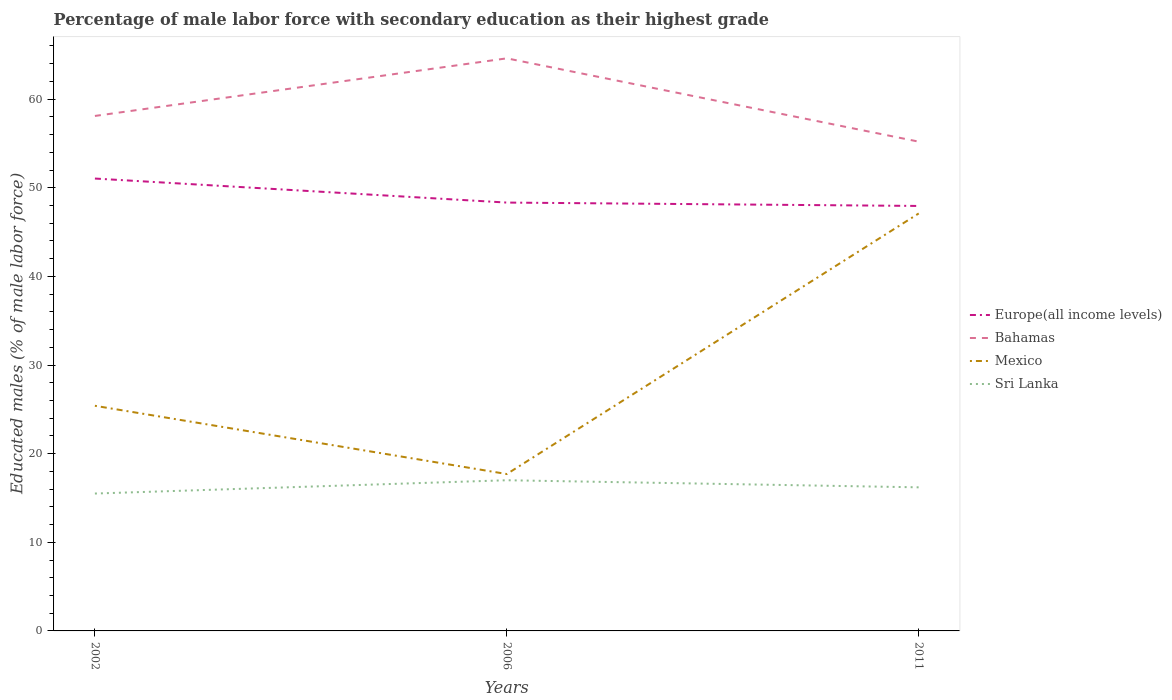Does the line corresponding to Europe(all income levels) intersect with the line corresponding to Bahamas?
Ensure brevity in your answer.  No. Across all years, what is the maximum percentage of male labor force with secondary education in Bahamas?
Your answer should be compact. 55.2. In which year was the percentage of male labor force with secondary education in Bahamas maximum?
Your answer should be compact. 2011. What is the total percentage of male labor force with secondary education in Europe(all income levels) in the graph?
Your answer should be compact. 3.09. What is the difference between the highest and the second highest percentage of male labor force with secondary education in Mexico?
Your response must be concise. 29.4. What is the difference between the highest and the lowest percentage of male labor force with secondary education in Sri Lanka?
Ensure brevity in your answer.  1. How many years are there in the graph?
Provide a short and direct response. 3. Are the values on the major ticks of Y-axis written in scientific E-notation?
Keep it short and to the point. No. Does the graph contain grids?
Give a very brief answer. No. Where does the legend appear in the graph?
Provide a succinct answer. Center right. How many legend labels are there?
Make the answer very short. 4. What is the title of the graph?
Make the answer very short. Percentage of male labor force with secondary education as their highest grade. What is the label or title of the X-axis?
Provide a succinct answer. Years. What is the label or title of the Y-axis?
Your answer should be compact. Educated males (% of male labor force). What is the Educated males (% of male labor force) of Europe(all income levels) in 2002?
Offer a terse response. 51.04. What is the Educated males (% of male labor force) in Bahamas in 2002?
Provide a succinct answer. 58.1. What is the Educated males (% of male labor force) in Mexico in 2002?
Your answer should be compact. 25.4. What is the Educated males (% of male labor force) in Europe(all income levels) in 2006?
Provide a short and direct response. 48.33. What is the Educated males (% of male labor force) of Bahamas in 2006?
Keep it short and to the point. 64.6. What is the Educated males (% of male labor force) in Mexico in 2006?
Give a very brief answer. 17.7. What is the Educated males (% of male labor force) of Sri Lanka in 2006?
Give a very brief answer. 17. What is the Educated males (% of male labor force) in Europe(all income levels) in 2011?
Keep it short and to the point. 47.95. What is the Educated males (% of male labor force) of Bahamas in 2011?
Offer a terse response. 55.2. What is the Educated males (% of male labor force) in Mexico in 2011?
Make the answer very short. 47.1. What is the Educated males (% of male labor force) of Sri Lanka in 2011?
Provide a succinct answer. 16.2. Across all years, what is the maximum Educated males (% of male labor force) in Europe(all income levels)?
Your answer should be very brief. 51.04. Across all years, what is the maximum Educated males (% of male labor force) in Bahamas?
Offer a very short reply. 64.6. Across all years, what is the maximum Educated males (% of male labor force) of Mexico?
Provide a succinct answer. 47.1. Across all years, what is the minimum Educated males (% of male labor force) of Europe(all income levels)?
Your answer should be very brief. 47.95. Across all years, what is the minimum Educated males (% of male labor force) in Bahamas?
Ensure brevity in your answer.  55.2. Across all years, what is the minimum Educated males (% of male labor force) of Mexico?
Offer a very short reply. 17.7. What is the total Educated males (% of male labor force) in Europe(all income levels) in the graph?
Provide a succinct answer. 147.31. What is the total Educated males (% of male labor force) of Bahamas in the graph?
Ensure brevity in your answer.  177.9. What is the total Educated males (% of male labor force) of Mexico in the graph?
Offer a very short reply. 90.2. What is the total Educated males (% of male labor force) in Sri Lanka in the graph?
Keep it short and to the point. 48.7. What is the difference between the Educated males (% of male labor force) of Europe(all income levels) in 2002 and that in 2006?
Offer a terse response. 2.71. What is the difference between the Educated males (% of male labor force) of Mexico in 2002 and that in 2006?
Your response must be concise. 7.7. What is the difference between the Educated males (% of male labor force) in Sri Lanka in 2002 and that in 2006?
Offer a terse response. -1.5. What is the difference between the Educated males (% of male labor force) in Europe(all income levels) in 2002 and that in 2011?
Give a very brief answer. 3.09. What is the difference between the Educated males (% of male labor force) in Bahamas in 2002 and that in 2011?
Provide a short and direct response. 2.9. What is the difference between the Educated males (% of male labor force) of Mexico in 2002 and that in 2011?
Give a very brief answer. -21.7. What is the difference between the Educated males (% of male labor force) of Sri Lanka in 2002 and that in 2011?
Your response must be concise. -0.7. What is the difference between the Educated males (% of male labor force) of Europe(all income levels) in 2006 and that in 2011?
Provide a short and direct response. 0.38. What is the difference between the Educated males (% of male labor force) of Mexico in 2006 and that in 2011?
Keep it short and to the point. -29.4. What is the difference between the Educated males (% of male labor force) in Europe(all income levels) in 2002 and the Educated males (% of male labor force) in Bahamas in 2006?
Offer a very short reply. -13.56. What is the difference between the Educated males (% of male labor force) of Europe(all income levels) in 2002 and the Educated males (% of male labor force) of Mexico in 2006?
Ensure brevity in your answer.  33.34. What is the difference between the Educated males (% of male labor force) of Europe(all income levels) in 2002 and the Educated males (% of male labor force) of Sri Lanka in 2006?
Provide a succinct answer. 34.04. What is the difference between the Educated males (% of male labor force) in Bahamas in 2002 and the Educated males (% of male labor force) in Mexico in 2006?
Ensure brevity in your answer.  40.4. What is the difference between the Educated males (% of male labor force) in Bahamas in 2002 and the Educated males (% of male labor force) in Sri Lanka in 2006?
Keep it short and to the point. 41.1. What is the difference between the Educated males (% of male labor force) of Mexico in 2002 and the Educated males (% of male labor force) of Sri Lanka in 2006?
Offer a terse response. 8.4. What is the difference between the Educated males (% of male labor force) of Europe(all income levels) in 2002 and the Educated males (% of male labor force) of Bahamas in 2011?
Offer a terse response. -4.16. What is the difference between the Educated males (% of male labor force) of Europe(all income levels) in 2002 and the Educated males (% of male labor force) of Mexico in 2011?
Provide a succinct answer. 3.94. What is the difference between the Educated males (% of male labor force) of Europe(all income levels) in 2002 and the Educated males (% of male labor force) of Sri Lanka in 2011?
Keep it short and to the point. 34.84. What is the difference between the Educated males (% of male labor force) in Bahamas in 2002 and the Educated males (% of male labor force) in Sri Lanka in 2011?
Your answer should be very brief. 41.9. What is the difference between the Educated males (% of male labor force) of Mexico in 2002 and the Educated males (% of male labor force) of Sri Lanka in 2011?
Your response must be concise. 9.2. What is the difference between the Educated males (% of male labor force) of Europe(all income levels) in 2006 and the Educated males (% of male labor force) of Bahamas in 2011?
Offer a terse response. -6.87. What is the difference between the Educated males (% of male labor force) in Europe(all income levels) in 2006 and the Educated males (% of male labor force) in Mexico in 2011?
Your response must be concise. 1.23. What is the difference between the Educated males (% of male labor force) in Europe(all income levels) in 2006 and the Educated males (% of male labor force) in Sri Lanka in 2011?
Make the answer very short. 32.13. What is the difference between the Educated males (% of male labor force) in Bahamas in 2006 and the Educated males (% of male labor force) in Mexico in 2011?
Your response must be concise. 17.5. What is the difference between the Educated males (% of male labor force) in Bahamas in 2006 and the Educated males (% of male labor force) in Sri Lanka in 2011?
Provide a short and direct response. 48.4. What is the average Educated males (% of male labor force) in Europe(all income levels) per year?
Provide a short and direct response. 49.1. What is the average Educated males (% of male labor force) of Bahamas per year?
Your answer should be compact. 59.3. What is the average Educated males (% of male labor force) in Mexico per year?
Ensure brevity in your answer.  30.07. What is the average Educated males (% of male labor force) in Sri Lanka per year?
Provide a short and direct response. 16.23. In the year 2002, what is the difference between the Educated males (% of male labor force) of Europe(all income levels) and Educated males (% of male labor force) of Bahamas?
Keep it short and to the point. -7.06. In the year 2002, what is the difference between the Educated males (% of male labor force) in Europe(all income levels) and Educated males (% of male labor force) in Mexico?
Offer a very short reply. 25.64. In the year 2002, what is the difference between the Educated males (% of male labor force) of Europe(all income levels) and Educated males (% of male labor force) of Sri Lanka?
Your response must be concise. 35.54. In the year 2002, what is the difference between the Educated males (% of male labor force) of Bahamas and Educated males (% of male labor force) of Mexico?
Make the answer very short. 32.7. In the year 2002, what is the difference between the Educated males (% of male labor force) in Bahamas and Educated males (% of male labor force) in Sri Lanka?
Offer a terse response. 42.6. In the year 2006, what is the difference between the Educated males (% of male labor force) of Europe(all income levels) and Educated males (% of male labor force) of Bahamas?
Offer a very short reply. -16.27. In the year 2006, what is the difference between the Educated males (% of male labor force) in Europe(all income levels) and Educated males (% of male labor force) in Mexico?
Your answer should be very brief. 30.63. In the year 2006, what is the difference between the Educated males (% of male labor force) of Europe(all income levels) and Educated males (% of male labor force) of Sri Lanka?
Provide a succinct answer. 31.33. In the year 2006, what is the difference between the Educated males (% of male labor force) in Bahamas and Educated males (% of male labor force) in Mexico?
Offer a very short reply. 46.9. In the year 2006, what is the difference between the Educated males (% of male labor force) in Bahamas and Educated males (% of male labor force) in Sri Lanka?
Make the answer very short. 47.6. In the year 2011, what is the difference between the Educated males (% of male labor force) of Europe(all income levels) and Educated males (% of male labor force) of Bahamas?
Provide a short and direct response. -7.25. In the year 2011, what is the difference between the Educated males (% of male labor force) of Europe(all income levels) and Educated males (% of male labor force) of Mexico?
Provide a short and direct response. 0.85. In the year 2011, what is the difference between the Educated males (% of male labor force) in Europe(all income levels) and Educated males (% of male labor force) in Sri Lanka?
Make the answer very short. 31.75. In the year 2011, what is the difference between the Educated males (% of male labor force) in Bahamas and Educated males (% of male labor force) in Sri Lanka?
Offer a terse response. 39. In the year 2011, what is the difference between the Educated males (% of male labor force) of Mexico and Educated males (% of male labor force) of Sri Lanka?
Provide a succinct answer. 30.9. What is the ratio of the Educated males (% of male labor force) in Europe(all income levels) in 2002 to that in 2006?
Ensure brevity in your answer.  1.06. What is the ratio of the Educated males (% of male labor force) of Bahamas in 2002 to that in 2006?
Keep it short and to the point. 0.9. What is the ratio of the Educated males (% of male labor force) of Mexico in 2002 to that in 2006?
Give a very brief answer. 1.44. What is the ratio of the Educated males (% of male labor force) of Sri Lanka in 2002 to that in 2006?
Provide a short and direct response. 0.91. What is the ratio of the Educated males (% of male labor force) in Europe(all income levels) in 2002 to that in 2011?
Provide a short and direct response. 1.06. What is the ratio of the Educated males (% of male labor force) in Bahamas in 2002 to that in 2011?
Your answer should be very brief. 1.05. What is the ratio of the Educated males (% of male labor force) in Mexico in 2002 to that in 2011?
Offer a terse response. 0.54. What is the ratio of the Educated males (% of male labor force) in Sri Lanka in 2002 to that in 2011?
Provide a succinct answer. 0.96. What is the ratio of the Educated males (% of male labor force) of Europe(all income levels) in 2006 to that in 2011?
Offer a very short reply. 1.01. What is the ratio of the Educated males (% of male labor force) in Bahamas in 2006 to that in 2011?
Offer a terse response. 1.17. What is the ratio of the Educated males (% of male labor force) in Mexico in 2006 to that in 2011?
Your answer should be very brief. 0.38. What is the ratio of the Educated males (% of male labor force) of Sri Lanka in 2006 to that in 2011?
Provide a succinct answer. 1.05. What is the difference between the highest and the second highest Educated males (% of male labor force) of Europe(all income levels)?
Provide a short and direct response. 2.71. What is the difference between the highest and the second highest Educated males (% of male labor force) in Bahamas?
Your answer should be very brief. 6.5. What is the difference between the highest and the second highest Educated males (% of male labor force) in Mexico?
Make the answer very short. 21.7. What is the difference between the highest and the lowest Educated males (% of male labor force) of Europe(all income levels)?
Make the answer very short. 3.09. What is the difference between the highest and the lowest Educated males (% of male labor force) of Bahamas?
Offer a terse response. 9.4. What is the difference between the highest and the lowest Educated males (% of male labor force) of Mexico?
Keep it short and to the point. 29.4. What is the difference between the highest and the lowest Educated males (% of male labor force) in Sri Lanka?
Your answer should be compact. 1.5. 